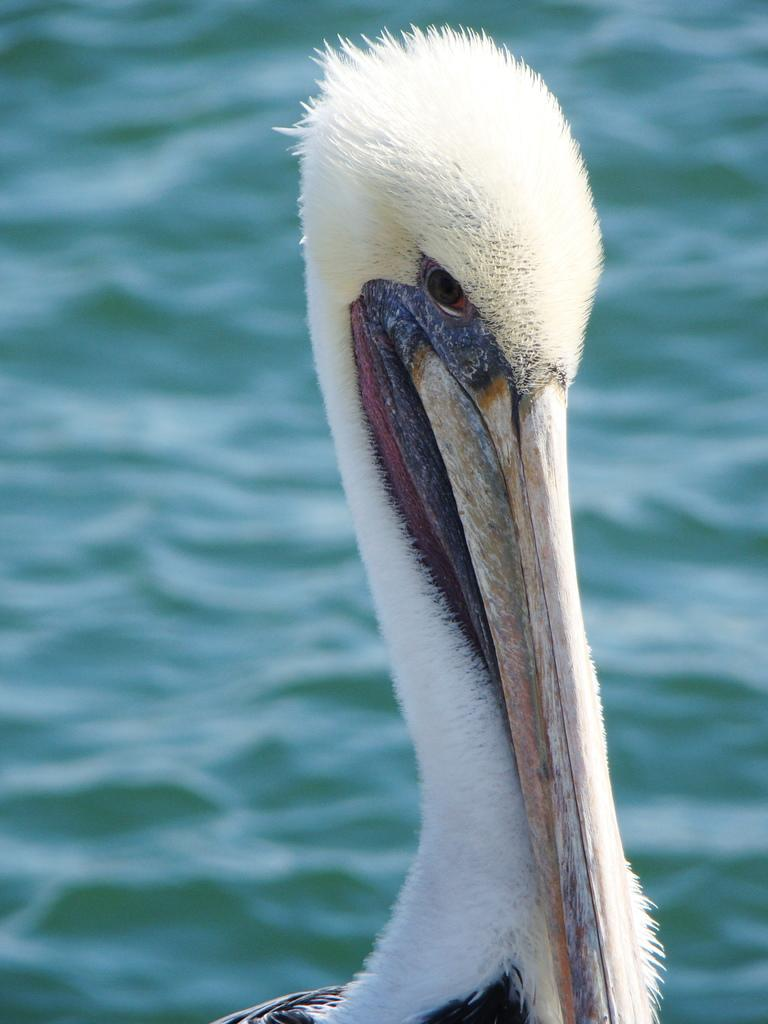What type of animal is in the image? There is a bird in the image. What colors can be seen on the bird? The bird has black, white, and red colors. What can be seen in the background of the image? There is water visible in the background of the image. What color is the water? The water has a green color. Can you see a comb being used by the bird in the image? There is no comb present in the image, and the bird is not using any object. What type of plants can be seen growing in the water in the image? There are no plants visible in the water in the image; only the bird and the green water are present. 